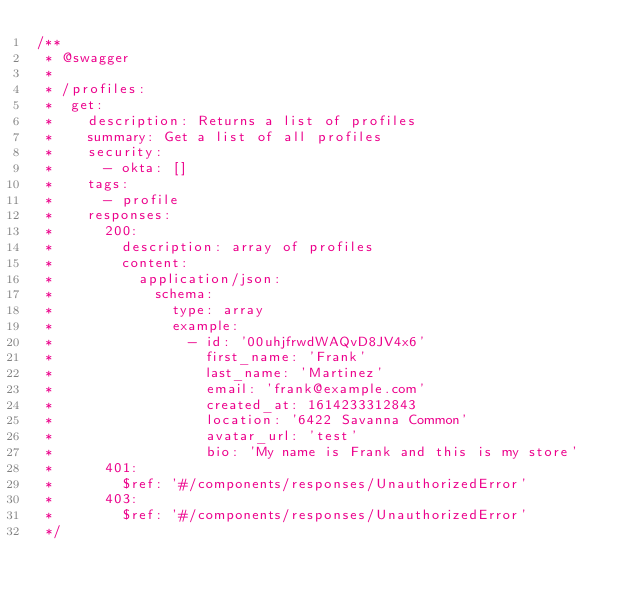Convert code to text. <code><loc_0><loc_0><loc_500><loc_500><_JavaScript_>/**
 * @swagger
 *
 * /profiles:
 *  get:
 *    description: Returns a list of profiles
 *    summary: Get a list of all profiles
 *    security:
 *      - okta: []
 *    tags:
 *      - profile
 *    responses:
 *      200:
 *        description: array of profiles
 *        content:
 *          application/json:
 *            schema:
 *              type: array
 *              example:
 *                - id: '00uhjfrwdWAQvD8JV4x6'
 *                  first_name: 'Frank'
 *                  last_name: 'Martinez'
 *                  email: 'frank@example.com'
 *                  created_at: 1614233312843
 *                  location: '6422 Savanna Common'
 *                  avatar_url: 'test'
 *                  bio: 'My name is Frank and this is my store'
 *      401:
 *        $ref: '#/components/responses/UnauthorizedError'
 *      403:
 *        $ref: '#/components/responses/UnauthorizedError'
 */
</code> 